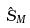Convert formula to latex. <formula><loc_0><loc_0><loc_500><loc_500>\hat { S } _ { M }</formula> 